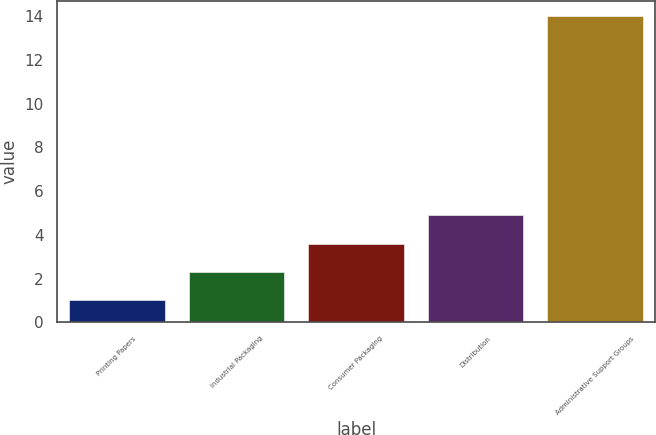Convert chart. <chart><loc_0><loc_0><loc_500><loc_500><bar_chart><fcel>Printing Papers<fcel>Industrial Packaging<fcel>Consumer Packaging<fcel>Distribution<fcel>Administrative Support Groups<nl><fcel>1<fcel>2.3<fcel>3.6<fcel>4.9<fcel>14<nl></chart> 